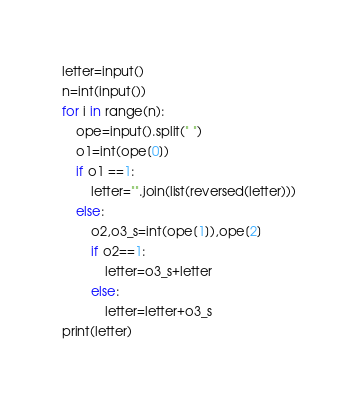<code> <loc_0><loc_0><loc_500><loc_500><_Python_>letter=input()
n=int(input())
for i in range(n):
    ope=input().split(" ")
    o1=int(ope[0])
    if o1 ==1:
        letter="".join(list(reversed(letter)))
    else:
        o2,o3_s=int(ope[1]),ope[2]
        if o2==1:
            letter=o3_s+letter
        else:
            letter=letter+o3_s
print(letter)</code> 